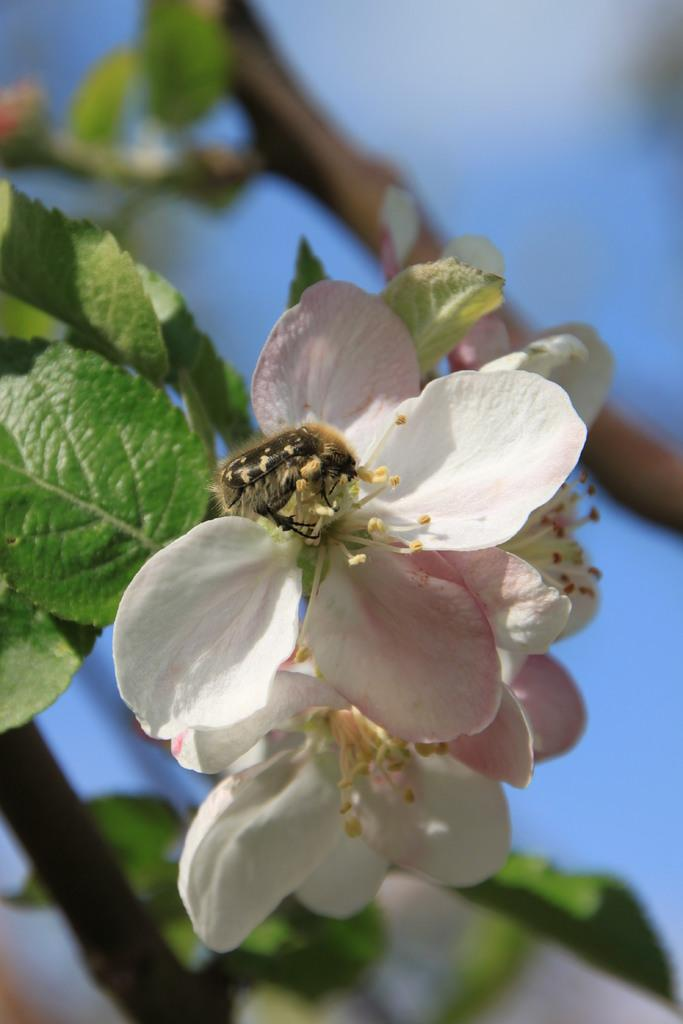What type of plant life is visible in the image? There are flowers and leaves in the image. Can you describe any living organisms present in the image? There is an insect on a flower in the image. What is the appearance of the background in the image? The background of the image is blurred. How many kittens are playing with the parent in the image? There are no kittens or parents present in the image; it features flowers, leaves, and an insect. 